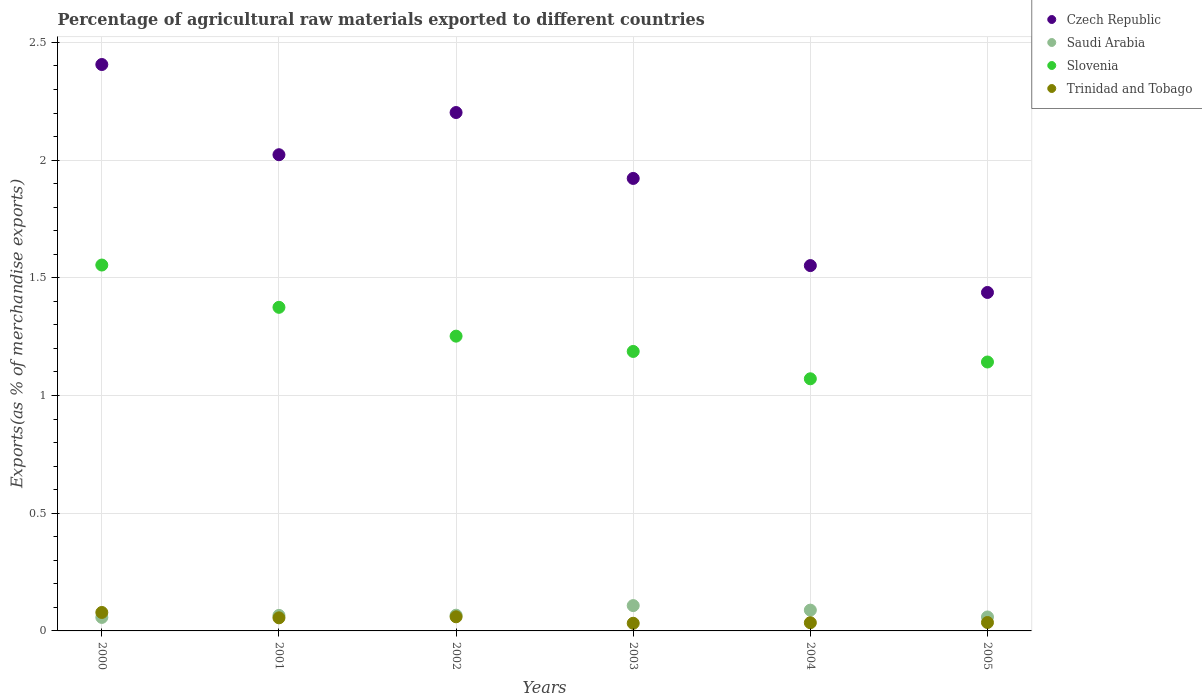How many different coloured dotlines are there?
Offer a very short reply. 4. Is the number of dotlines equal to the number of legend labels?
Keep it short and to the point. Yes. What is the percentage of exports to different countries in Saudi Arabia in 2004?
Keep it short and to the point. 0.09. Across all years, what is the maximum percentage of exports to different countries in Trinidad and Tobago?
Give a very brief answer. 0.08. Across all years, what is the minimum percentage of exports to different countries in Slovenia?
Your answer should be compact. 1.07. What is the total percentage of exports to different countries in Saudi Arabia in the graph?
Keep it short and to the point. 0.45. What is the difference between the percentage of exports to different countries in Saudi Arabia in 2002 and that in 2005?
Your answer should be compact. 0.01. What is the difference between the percentage of exports to different countries in Czech Republic in 2003 and the percentage of exports to different countries in Saudi Arabia in 2000?
Your answer should be very brief. 1.86. What is the average percentage of exports to different countries in Trinidad and Tobago per year?
Offer a terse response. 0.05. In the year 2003, what is the difference between the percentage of exports to different countries in Trinidad and Tobago and percentage of exports to different countries in Slovenia?
Offer a very short reply. -1.15. In how many years, is the percentage of exports to different countries in Trinidad and Tobago greater than 1.1 %?
Your answer should be very brief. 0. What is the ratio of the percentage of exports to different countries in Saudi Arabia in 2002 to that in 2003?
Offer a terse response. 0.62. Is the difference between the percentage of exports to different countries in Trinidad and Tobago in 2000 and 2001 greater than the difference between the percentage of exports to different countries in Slovenia in 2000 and 2001?
Your answer should be compact. No. What is the difference between the highest and the second highest percentage of exports to different countries in Slovenia?
Provide a succinct answer. 0.18. What is the difference between the highest and the lowest percentage of exports to different countries in Slovenia?
Ensure brevity in your answer.  0.48. Is the sum of the percentage of exports to different countries in Trinidad and Tobago in 2000 and 2005 greater than the maximum percentage of exports to different countries in Slovenia across all years?
Your answer should be compact. No. Is it the case that in every year, the sum of the percentage of exports to different countries in Czech Republic and percentage of exports to different countries in Slovenia  is greater than the sum of percentage of exports to different countries in Trinidad and Tobago and percentage of exports to different countries in Saudi Arabia?
Make the answer very short. No. Does the percentage of exports to different countries in Saudi Arabia monotonically increase over the years?
Make the answer very short. No. Is the percentage of exports to different countries in Trinidad and Tobago strictly greater than the percentage of exports to different countries in Czech Republic over the years?
Your response must be concise. No. Is the percentage of exports to different countries in Saudi Arabia strictly less than the percentage of exports to different countries in Czech Republic over the years?
Offer a terse response. Yes. How many dotlines are there?
Your answer should be very brief. 4. How many years are there in the graph?
Your answer should be very brief. 6. Are the values on the major ticks of Y-axis written in scientific E-notation?
Your answer should be very brief. No. Where does the legend appear in the graph?
Make the answer very short. Top right. How many legend labels are there?
Your answer should be very brief. 4. What is the title of the graph?
Keep it short and to the point. Percentage of agricultural raw materials exported to different countries. Does "Guam" appear as one of the legend labels in the graph?
Keep it short and to the point. No. What is the label or title of the X-axis?
Make the answer very short. Years. What is the label or title of the Y-axis?
Offer a terse response. Exports(as % of merchandise exports). What is the Exports(as % of merchandise exports) of Czech Republic in 2000?
Your answer should be compact. 2.41. What is the Exports(as % of merchandise exports) of Saudi Arabia in 2000?
Provide a short and direct response. 0.06. What is the Exports(as % of merchandise exports) in Slovenia in 2000?
Give a very brief answer. 1.55. What is the Exports(as % of merchandise exports) of Trinidad and Tobago in 2000?
Make the answer very short. 0.08. What is the Exports(as % of merchandise exports) of Czech Republic in 2001?
Offer a very short reply. 2.02. What is the Exports(as % of merchandise exports) in Saudi Arabia in 2001?
Make the answer very short. 0.07. What is the Exports(as % of merchandise exports) in Slovenia in 2001?
Your answer should be very brief. 1.37. What is the Exports(as % of merchandise exports) in Trinidad and Tobago in 2001?
Offer a very short reply. 0.06. What is the Exports(as % of merchandise exports) of Czech Republic in 2002?
Make the answer very short. 2.2. What is the Exports(as % of merchandise exports) of Saudi Arabia in 2002?
Keep it short and to the point. 0.07. What is the Exports(as % of merchandise exports) of Slovenia in 2002?
Keep it short and to the point. 1.25. What is the Exports(as % of merchandise exports) in Trinidad and Tobago in 2002?
Offer a terse response. 0.06. What is the Exports(as % of merchandise exports) of Czech Republic in 2003?
Give a very brief answer. 1.92. What is the Exports(as % of merchandise exports) in Saudi Arabia in 2003?
Your answer should be very brief. 0.11. What is the Exports(as % of merchandise exports) in Slovenia in 2003?
Keep it short and to the point. 1.19. What is the Exports(as % of merchandise exports) in Trinidad and Tobago in 2003?
Offer a very short reply. 0.03. What is the Exports(as % of merchandise exports) of Czech Republic in 2004?
Provide a short and direct response. 1.55. What is the Exports(as % of merchandise exports) in Saudi Arabia in 2004?
Your answer should be very brief. 0.09. What is the Exports(as % of merchandise exports) of Slovenia in 2004?
Keep it short and to the point. 1.07. What is the Exports(as % of merchandise exports) in Trinidad and Tobago in 2004?
Provide a short and direct response. 0.03. What is the Exports(as % of merchandise exports) of Czech Republic in 2005?
Make the answer very short. 1.44. What is the Exports(as % of merchandise exports) in Saudi Arabia in 2005?
Ensure brevity in your answer.  0.06. What is the Exports(as % of merchandise exports) in Slovenia in 2005?
Keep it short and to the point. 1.14. What is the Exports(as % of merchandise exports) in Trinidad and Tobago in 2005?
Make the answer very short. 0.04. Across all years, what is the maximum Exports(as % of merchandise exports) of Czech Republic?
Ensure brevity in your answer.  2.41. Across all years, what is the maximum Exports(as % of merchandise exports) of Saudi Arabia?
Your response must be concise. 0.11. Across all years, what is the maximum Exports(as % of merchandise exports) in Slovenia?
Your answer should be compact. 1.55. Across all years, what is the maximum Exports(as % of merchandise exports) in Trinidad and Tobago?
Make the answer very short. 0.08. Across all years, what is the minimum Exports(as % of merchandise exports) of Czech Republic?
Ensure brevity in your answer.  1.44. Across all years, what is the minimum Exports(as % of merchandise exports) of Saudi Arabia?
Your response must be concise. 0.06. Across all years, what is the minimum Exports(as % of merchandise exports) of Slovenia?
Offer a very short reply. 1.07. Across all years, what is the minimum Exports(as % of merchandise exports) of Trinidad and Tobago?
Keep it short and to the point. 0.03. What is the total Exports(as % of merchandise exports) in Czech Republic in the graph?
Provide a succinct answer. 11.54. What is the total Exports(as % of merchandise exports) in Saudi Arabia in the graph?
Provide a short and direct response. 0.45. What is the total Exports(as % of merchandise exports) in Slovenia in the graph?
Provide a short and direct response. 7.58. What is the total Exports(as % of merchandise exports) in Trinidad and Tobago in the graph?
Ensure brevity in your answer.  0.3. What is the difference between the Exports(as % of merchandise exports) in Czech Republic in 2000 and that in 2001?
Provide a succinct answer. 0.38. What is the difference between the Exports(as % of merchandise exports) of Saudi Arabia in 2000 and that in 2001?
Keep it short and to the point. -0.01. What is the difference between the Exports(as % of merchandise exports) in Slovenia in 2000 and that in 2001?
Your answer should be compact. 0.18. What is the difference between the Exports(as % of merchandise exports) of Trinidad and Tobago in 2000 and that in 2001?
Make the answer very short. 0.02. What is the difference between the Exports(as % of merchandise exports) of Czech Republic in 2000 and that in 2002?
Keep it short and to the point. 0.2. What is the difference between the Exports(as % of merchandise exports) in Saudi Arabia in 2000 and that in 2002?
Offer a terse response. -0.01. What is the difference between the Exports(as % of merchandise exports) in Slovenia in 2000 and that in 2002?
Make the answer very short. 0.3. What is the difference between the Exports(as % of merchandise exports) of Trinidad and Tobago in 2000 and that in 2002?
Provide a short and direct response. 0.02. What is the difference between the Exports(as % of merchandise exports) of Czech Republic in 2000 and that in 2003?
Provide a short and direct response. 0.48. What is the difference between the Exports(as % of merchandise exports) in Saudi Arabia in 2000 and that in 2003?
Your answer should be compact. -0.05. What is the difference between the Exports(as % of merchandise exports) of Slovenia in 2000 and that in 2003?
Offer a terse response. 0.37. What is the difference between the Exports(as % of merchandise exports) in Trinidad and Tobago in 2000 and that in 2003?
Offer a very short reply. 0.05. What is the difference between the Exports(as % of merchandise exports) of Czech Republic in 2000 and that in 2004?
Your response must be concise. 0.85. What is the difference between the Exports(as % of merchandise exports) of Saudi Arabia in 2000 and that in 2004?
Make the answer very short. -0.03. What is the difference between the Exports(as % of merchandise exports) in Slovenia in 2000 and that in 2004?
Offer a very short reply. 0.48. What is the difference between the Exports(as % of merchandise exports) in Trinidad and Tobago in 2000 and that in 2004?
Provide a succinct answer. 0.04. What is the difference between the Exports(as % of merchandise exports) in Czech Republic in 2000 and that in 2005?
Keep it short and to the point. 0.97. What is the difference between the Exports(as % of merchandise exports) in Saudi Arabia in 2000 and that in 2005?
Offer a terse response. -0. What is the difference between the Exports(as % of merchandise exports) in Slovenia in 2000 and that in 2005?
Your answer should be very brief. 0.41. What is the difference between the Exports(as % of merchandise exports) in Trinidad and Tobago in 2000 and that in 2005?
Offer a very short reply. 0.04. What is the difference between the Exports(as % of merchandise exports) in Czech Republic in 2001 and that in 2002?
Your answer should be very brief. -0.18. What is the difference between the Exports(as % of merchandise exports) in Saudi Arabia in 2001 and that in 2002?
Ensure brevity in your answer.  -0. What is the difference between the Exports(as % of merchandise exports) of Slovenia in 2001 and that in 2002?
Your response must be concise. 0.12. What is the difference between the Exports(as % of merchandise exports) of Trinidad and Tobago in 2001 and that in 2002?
Keep it short and to the point. -0. What is the difference between the Exports(as % of merchandise exports) of Czech Republic in 2001 and that in 2003?
Offer a very short reply. 0.1. What is the difference between the Exports(as % of merchandise exports) of Saudi Arabia in 2001 and that in 2003?
Ensure brevity in your answer.  -0.04. What is the difference between the Exports(as % of merchandise exports) of Slovenia in 2001 and that in 2003?
Offer a terse response. 0.19. What is the difference between the Exports(as % of merchandise exports) of Trinidad and Tobago in 2001 and that in 2003?
Your answer should be compact. 0.02. What is the difference between the Exports(as % of merchandise exports) in Czech Republic in 2001 and that in 2004?
Keep it short and to the point. 0.47. What is the difference between the Exports(as % of merchandise exports) of Saudi Arabia in 2001 and that in 2004?
Ensure brevity in your answer.  -0.02. What is the difference between the Exports(as % of merchandise exports) of Slovenia in 2001 and that in 2004?
Make the answer very short. 0.3. What is the difference between the Exports(as % of merchandise exports) of Trinidad and Tobago in 2001 and that in 2004?
Your answer should be very brief. 0.02. What is the difference between the Exports(as % of merchandise exports) in Czech Republic in 2001 and that in 2005?
Keep it short and to the point. 0.59. What is the difference between the Exports(as % of merchandise exports) of Saudi Arabia in 2001 and that in 2005?
Make the answer very short. 0.01. What is the difference between the Exports(as % of merchandise exports) in Slovenia in 2001 and that in 2005?
Keep it short and to the point. 0.23. What is the difference between the Exports(as % of merchandise exports) of Trinidad and Tobago in 2001 and that in 2005?
Provide a short and direct response. 0.02. What is the difference between the Exports(as % of merchandise exports) of Czech Republic in 2002 and that in 2003?
Keep it short and to the point. 0.28. What is the difference between the Exports(as % of merchandise exports) in Saudi Arabia in 2002 and that in 2003?
Give a very brief answer. -0.04. What is the difference between the Exports(as % of merchandise exports) in Slovenia in 2002 and that in 2003?
Provide a succinct answer. 0.07. What is the difference between the Exports(as % of merchandise exports) in Trinidad and Tobago in 2002 and that in 2003?
Provide a short and direct response. 0.03. What is the difference between the Exports(as % of merchandise exports) of Czech Republic in 2002 and that in 2004?
Your answer should be compact. 0.65. What is the difference between the Exports(as % of merchandise exports) of Saudi Arabia in 2002 and that in 2004?
Make the answer very short. -0.02. What is the difference between the Exports(as % of merchandise exports) of Slovenia in 2002 and that in 2004?
Offer a very short reply. 0.18. What is the difference between the Exports(as % of merchandise exports) in Trinidad and Tobago in 2002 and that in 2004?
Offer a terse response. 0.03. What is the difference between the Exports(as % of merchandise exports) of Czech Republic in 2002 and that in 2005?
Give a very brief answer. 0.76. What is the difference between the Exports(as % of merchandise exports) of Saudi Arabia in 2002 and that in 2005?
Keep it short and to the point. 0.01. What is the difference between the Exports(as % of merchandise exports) of Slovenia in 2002 and that in 2005?
Ensure brevity in your answer.  0.11. What is the difference between the Exports(as % of merchandise exports) in Trinidad and Tobago in 2002 and that in 2005?
Offer a terse response. 0.02. What is the difference between the Exports(as % of merchandise exports) of Czech Republic in 2003 and that in 2004?
Give a very brief answer. 0.37. What is the difference between the Exports(as % of merchandise exports) of Saudi Arabia in 2003 and that in 2004?
Your answer should be very brief. 0.02. What is the difference between the Exports(as % of merchandise exports) in Slovenia in 2003 and that in 2004?
Ensure brevity in your answer.  0.12. What is the difference between the Exports(as % of merchandise exports) in Trinidad and Tobago in 2003 and that in 2004?
Offer a terse response. -0. What is the difference between the Exports(as % of merchandise exports) in Czech Republic in 2003 and that in 2005?
Your response must be concise. 0.48. What is the difference between the Exports(as % of merchandise exports) of Saudi Arabia in 2003 and that in 2005?
Give a very brief answer. 0.05. What is the difference between the Exports(as % of merchandise exports) in Slovenia in 2003 and that in 2005?
Provide a succinct answer. 0.04. What is the difference between the Exports(as % of merchandise exports) in Trinidad and Tobago in 2003 and that in 2005?
Give a very brief answer. -0. What is the difference between the Exports(as % of merchandise exports) of Czech Republic in 2004 and that in 2005?
Your response must be concise. 0.11. What is the difference between the Exports(as % of merchandise exports) of Saudi Arabia in 2004 and that in 2005?
Give a very brief answer. 0.03. What is the difference between the Exports(as % of merchandise exports) of Slovenia in 2004 and that in 2005?
Offer a terse response. -0.07. What is the difference between the Exports(as % of merchandise exports) of Trinidad and Tobago in 2004 and that in 2005?
Your response must be concise. -0. What is the difference between the Exports(as % of merchandise exports) of Czech Republic in 2000 and the Exports(as % of merchandise exports) of Saudi Arabia in 2001?
Your response must be concise. 2.34. What is the difference between the Exports(as % of merchandise exports) of Czech Republic in 2000 and the Exports(as % of merchandise exports) of Slovenia in 2001?
Provide a short and direct response. 1.03. What is the difference between the Exports(as % of merchandise exports) of Czech Republic in 2000 and the Exports(as % of merchandise exports) of Trinidad and Tobago in 2001?
Offer a terse response. 2.35. What is the difference between the Exports(as % of merchandise exports) in Saudi Arabia in 2000 and the Exports(as % of merchandise exports) in Slovenia in 2001?
Your response must be concise. -1.32. What is the difference between the Exports(as % of merchandise exports) in Saudi Arabia in 2000 and the Exports(as % of merchandise exports) in Trinidad and Tobago in 2001?
Keep it short and to the point. 0. What is the difference between the Exports(as % of merchandise exports) in Slovenia in 2000 and the Exports(as % of merchandise exports) in Trinidad and Tobago in 2001?
Your response must be concise. 1.5. What is the difference between the Exports(as % of merchandise exports) of Czech Republic in 2000 and the Exports(as % of merchandise exports) of Saudi Arabia in 2002?
Keep it short and to the point. 2.34. What is the difference between the Exports(as % of merchandise exports) in Czech Republic in 2000 and the Exports(as % of merchandise exports) in Slovenia in 2002?
Provide a succinct answer. 1.15. What is the difference between the Exports(as % of merchandise exports) of Czech Republic in 2000 and the Exports(as % of merchandise exports) of Trinidad and Tobago in 2002?
Ensure brevity in your answer.  2.35. What is the difference between the Exports(as % of merchandise exports) of Saudi Arabia in 2000 and the Exports(as % of merchandise exports) of Slovenia in 2002?
Provide a short and direct response. -1.19. What is the difference between the Exports(as % of merchandise exports) of Saudi Arabia in 2000 and the Exports(as % of merchandise exports) of Trinidad and Tobago in 2002?
Keep it short and to the point. -0. What is the difference between the Exports(as % of merchandise exports) of Slovenia in 2000 and the Exports(as % of merchandise exports) of Trinidad and Tobago in 2002?
Offer a terse response. 1.49. What is the difference between the Exports(as % of merchandise exports) of Czech Republic in 2000 and the Exports(as % of merchandise exports) of Saudi Arabia in 2003?
Offer a very short reply. 2.3. What is the difference between the Exports(as % of merchandise exports) in Czech Republic in 2000 and the Exports(as % of merchandise exports) in Slovenia in 2003?
Provide a short and direct response. 1.22. What is the difference between the Exports(as % of merchandise exports) of Czech Republic in 2000 and the Exports(as % of merchandise exports) of Trinidad and Tobago in 2003?
Keep it short and to the point. 2.37. What is the difference between the Exports(as % of merchandise exports) of Saudi Arabia in 2000 and the Exports(as % of merchandise exports) of Slovenia in 2003?
Make the answer very short. -1.13. What is the difference between the Exports(as % of merchandise exports) in Saudi Arabia in 2000 and the Exports(as % of merchandise exports) in Trinidad and Tobago in 2003?
Offer a terse response. 0.02. What is the difference between the Exports(as % of merchandise exports) of Slovenia in 2000 and the Exports(as % of merchandise exports) of Trinidad and Tobago in 2003?
Offer a terse response. 1.52. What is the difference between the Exports(as % of merchandise exports) of Czech Republic in 2000 and the Exports(as % of merchandise exports) of Saudi Arabia in 2004?
Keep it short and to the point. 2.32. What is the difference between the Exports(as % of merchandise exports) in Czech Republic in 2000 and the Exports(as % of merchandise exports) in Slovenia in 2004?
Your answer should be compact. 1.33. What is the difference between the Exports(as % of merchandise exports) in Czech Republic in 2000 and the Exports(as % of merchandise exports) in Trinidad and Tobago in 2004?
Your response must be concise. 2.37. What is the difference between the Exports(as % of merchandise exports) of Saudi Arabia in 2000 and the Exports(as % of merchandise exports) of Slovenia in 2004?
Your answer should be very brief. -1.01. What is the difference between the Exports(as % of merchandise exports) of Saudi Arabia in 2000 and the Exports(as % of merchandise exports) of Trinidad and Tobago in 2004?
Your answer should be very brief. 0.02. What is the difference between the Exports(as % of merchandise exports) in Slovenia in 2000 and the Exports(as % of merchandise exports) in Trinidad and Tobago in 2004?
Keep it short and to the point. 1.52. What is the difference between the Exports(as % of merchandise exports) in Czech Republic in 2000 and the Exports(as % of merchandise exports) in Saudi Arabia in 2005?
Give a very brief answer. 2.35. What is the difference between the Exports(as % of merchandise exports) in Czech Republic in 2000 and the Exports(as % of merchandise exports) in Slovenia in 2005?
Your response must be concise. 1.26. What is the difference between the Exports(as % of merchandise exports) in Czech Republic in 2000 and the Exports(as % of merchandise exports) in Trinidad and Tobago in 2005?
Make the answer very short. 2.37. What is the difference between the Exports(as % of merchandise exports) in Saudi Arabia in 2000 and the Exports(as % of merchandise exports) in Slovenia in 2005?
Offer a terse response. -1.08. What is the difference between the Exports(as % of merchandise exports) in Saudi Arabia in 2000 and the Exports(as % of merchandise exports) in Trinidad and Tobago in 2005?
Ensure brevity in your answer.  0.02. What is the difference between the Exports(as % of merchandise exports) in Slovenia in 2000 and the Exports(as % of merchandise exports) in Trinidad and Tobago in 2005?
Your response must be concise. 1.52. What is the difference between the Exports(as % of merchandise exports) in Czech Republic in 2001 and the Exports(as % of merchandise exports) in Saudi Arabia in 2002?
Give a very brief answer. 1.96. What is the difference between the Exports(as % of merchandise exports) of Czech Republic in 2001 and the Exports(as % of merchandise exports) of Slovenia in 2002?
Your response must be concise. 0.77. What is the difference between the Exports(as % of merchandise exports) in Czech Republic in 2001 and the Exports(as % of merchandise exports) in Trinidad and Tobago in 2002?
Keep it short and to the point. 1.96. What is the difference between the Exports(as % of merchandise exports) in Saudi Arabia in 2001 and the Exports(as % of merchandise exports) in Slovenia in 2002?
Keep it short and to the point. -1.19. What is the difference between the Exports(as % of merchandise exports) in Saudi Arabia in 2001 and the Exports(as % of merchandise exports) in Trinidad and Tobago in 2002?
Offer a very short reply. 0.01. What is the difference between the Exports(as % of merchandise exports) of Slovenia in 2001 and the Exports(as % of merchandise exports) of Trinidad and Tobago in 2002?
Ensure brevity in your answer.  1.31. What is the difference between the Exports(as % of merchandise exports) of Czech Republic in 2001 and the Exports(as % of merchandise exports) of Saudi Arabia in 2003?
Offer a very short reply. 1.92. What is the difference between the Exports(as % of merchandise exports) of Czech Republic in 2001 and the Exports(as % of merchandise exports) of Slovenia in 2003?
Give a very brief answer. 0.84. What is the difference between the Exports(as % of merchandise exports) in Czech Republic in 2001 and the Exports(as % of merchandise exports) in Trinidad and Tobago in 2003?
Ensure brevity in your answer.  1.99. What is the difference between the Exports(as % of merchandise exports) in Saudi Arabia in 2001 and the Exports(as % of merchandise exports) in Slovenia in 2003?
Offer a terse response. -1.12. What is the difference between the Exports(as % of merchandise exports) in Slovenia in 2001 and the Exports(as % of merchandise exports) in Trinidad and Tobago in 2003?
Your answer should be very brief. 1.34. What is the difference between the Exports(as % of merchandise exports) of Czech Republic in 2001 and the Exports(as % of merchandise exports) of Saudi Arabia in 2004?
Your answer should be very brief. 1.93. What is the difference between the Exports(as % of merchandise exports) in Czech Republic in 2001 and the Exports(as % of merchandise exports) in Slovenia in 2004?
Provide a succinct answer. 0.95. What is the difference between the Exports(as % of merchandise exports) in Czech Republic in 2001 and the Exports(as % of merchandise exports) in Trinidad and Tobago in 2004?
Provide a succinct answer. 1.99. What is the difference between the Exports(as % of merchandise exports) in Saudi Arabia in 2001 and the Exports(as % of merchandise exports) in Slovenia in 2004?
Your answer should be very brief. -1.01. What is the difference between the Exports(as % of merchandise exports) in Saudi Arabia in 2001 and the Exports(as % of merchandise exports) in Trinidad and Tobago in 2004?
Offer a terse response. 0.03. What is the difference between the Exports(as % of merchandise exports) of Slovenia in 2001 and the Exports(as % of merchandise exports) of Trinidad and Tobago in 2004?
Offer a very short reply. 1.34. What is the difference between the Exports(as % of merchandise exports) of Czech Republic in 2001 and the Exports(as % of merchandise exports) of Saudi Arabia in 2005?
Keep it short and to the point. 1.96. What is the difference between the Exports(as % of merchandise exports) in Czech Republic in 2001 and the Exports(as % of merchandise exports) in Slovenia in 2005?
Make the answer very short. 0.88. What is the difference between the Exports(as % of merchandise exports) in Czech Republic in 2001 and the Exports(as % of merchandise exports) in Trinidad and Tobago in 2005?
Provide a succinct answer. 1.99. What is the difference between the Exports(as % of merchandise exports) of Saudi Arabia in 2001 and the Exports(as % of merchandise exports) of Slovenia in 2005?
Keep it short and to the point. -1.08. What is the difference between the Exports(as % of merchandise exports) of Saudi Arabia in 2001 and the Exports(as % of merchandise exports) of Trinidad and Tobago in 2005?
Give a very brief answer. 0.03. What is the difference between the Exports(as % of merchandise exports) of Slovenia in 2001 and the Exports(as % of merchandise exports) of Trinidad and Tobago in 2005?
Your response must be concise. 1.34. What is the difference between the Exports(as % of merchandise exports) in Czech Republic in 2002 and the Exports(as % of merchandise exports) in Saudi Arabia in 2003?
Provide a succinct answer. 2.09. What is the difference between the Exports(as % of merchandise exports) in Czech Republic in 2002 and the Exports(as % of merchandise exports) in Slovenia in 2003?
Provide a succinct answer. 1.01. What is the difference between the Exports(as % of merchandise exports) in Czech Republic in 2002 and the Exports(as % of merchandise exports) in Trinidad and Tobago in 2003?
Ensure brevity in your answer.  2.17. What is the difference between the Exports(as % of merchandise exports) of Saudi Arabia in 2002 and the Exports(as % of merchandise exports) of Slovenia in 2003?
Make the answer very short. -1.12. What is the difference between the Exports(as % of merchandise exports) in Saudi Arabia in 2002 and the Exports(as % of merchandise exports) in Trinidad and Tobago in 2003?
Offer a terse response. 0.03. What is the difference between the Exports(as % of merchandise exports) of Slovenia in 2002 and the Exports(as % of merchandise exports) of Trinidad and Tobago in 2003?
Ensure brevity in your answer.  1.22. What is the difference between the Exports(as % of merchandise exports) of Czech Republic in 2002 and the Exports(as % of merchandise exports) of Saudi Arabia in 2004?
Your answer should be very brief. 2.11. What is the difference between the Exports(as % of merchandise exports) in Czech Republic in 2002 and the Exports(as % of merchandise exports) in Slovenia in 2004?
Provide a succinct answer. 1.13. What is the difference between the Exports(as % of merchandise exports) in Czech Republic in 2002 and the Exports(as % of merchandise exports) in Trinidad and Tobago in 2004?
Offer a terse response. 2.17. What is the difference between the Exports(as % of merchandise exports) in Saudi Arabia in 2002 and the Exports(as % of merchandise exports) in Slovenia in 2004?
Offer a very short reply. -1. What is the difference between the Exports(as % of merchandise exports) in Saudi Arabia in 2002 and the Exports(as % of merchandise exports) in Trinidad and Tobago in 2004?
Provide a succinct answer. 0.03. What is the difference between the Exports(as % of merchandise exports) in Slovenia in 2002 and the Exports(as % of merchandise exports) in Trinidad and Tobago in 2004?
Offer a very short reply. 1.22. What is the difference between the Exports(as % of merchandise exports) in Czech Republic in 2002 and the Exports(as % of merchandise exports) in Saudi Arabia in 2005?
Make the answer very short. 2.14. What is the difference between the Exports(as % of merchandise exports) in Czech Republic in 2002 and the Exports(as % of merchandise exports) in Slovenia in 2005?
Give a very brief answer. 1.06. What is the difference between the Exports(as % of merchandise exports) of Czech Republic in 2002 and the Exports(as % of merchandise exports) of Trinidad and Tobago in 2005?
Your answer should be compact. 2.17. What is the difference between the Exports(as % of merchandise exports) of Saudi Arabia in 2002 and the Exports(as % of merchandise exports) of Slovenia in 2005?
Provide a succinct answer. -1.08. What is the difference between the Exports(as % of merchandise exports) in Saudi Arabia in 2002 and the Exports(as % of merchandise exports) in Trinidad and Tobago in 2005?
Make the answer very short. 0.03. What is the difference between the Exports(as % of merchandise exports) in Slovenia in 2002 and the Exports(as % of merchandise exports) in Trinidad and Tobago in 2005?
Keep it short and to the point. 1.22. What is the difference between the Exports(as % of merchandise exports) of Czech Republic in 2003 and the Exports(as % of merchandise exports) of Saudi Arabia in 2004?
Your answer should be very brief. 1.83. What is the difference between the Exports(as % of merchandise exports) of Czech Republic in 2003 and the Exports(as % of merchandise exports) of Slovenia in 2004?
Offer a terse response. 0.85. What is the difference between the Exports(as % of merchandise exports) in Czech Republic in 2003 and the Exports(as % of merchandise exports) in Trinidad and Tobago in 2004?
Provide a succinct answer. 1.89. What is the difference between the Exports(as % of merchandise exports) of Saudi Arabia in 2003 and the Exports(as % of merchandise exports) of Slovenia in 2004?
Ensure brevity in your answer.  -0.96. What is the difference between the Exports(as % of merchandise exports) in Saudi Arabia in 2003 and the Exports(as % of merchandise exports) in Trinidad and Tobago in 2004?
Offer a terse response. 0.07. What is the difference between the Exports(as % of merchandise exports) of Slovenia in 2003 and the Exports(as % of merchandise exports) of Trinidad and Tobago in 2004?
Your answer should be very brief. 1.15. What is the difference between the Exports(as % of merchandise exports) in Czech Republic in 2003 and the Exports(as % of merchandise exports) in Saudi Arabia in 2005?
Keep it short and to the point. 1.86. What is the difference between the Exports(as % of merchandise exports) of Czech Republic in 2003 and the Exports(as % of merchandise exports) of Slovenia in 2005?
Your response must be concise. 0.78. What is the difference between the Exports(as % of merchandise exports) of Czech Republic in 2003 and the Exports(as % of merchandise exports) of Trinidad and Tobago in 2005?
Make the answer very short. 1.89. What is the difference between the Exports(as % of merchandise exports) of Saudi Arabia in 2003 and the Exports(as % of merchandise exports) of Slovenia in 2005?
Ensure brevity in your answer.  -1.03. What is the difference between the Exports(as % of merchandise exports) of Saudi Arabia in 2003 and the Exports(as % of merchandise exports) of Trinidad and Tobago in 2005?
Give a very brief answer. 0.07. What is the difference between the Exports(as % of merchandise exports) in Slovenia in 2003 and the Exports(as % of merchandise exports) in Trinidad and Tobago in 2005?
Ensure brevity in your answer.  1.15. What is the difference between the Exports(as % of merchandise exports) in Czech Republic in 2004 and the Exports(as % of merchandise exports) in Saudi Arabia in 2005?
Ensure brevity in your answer.  1.49. What is the difference between the Exports(as % of merchandise exports) of Czech Republic in 2004 and the Exports(as % of merchandise exports) of Slovenia in 2005?
Your response must be concise. 0.41. What is the difference between the Exports(as % of merchandise exports) in Czech Republic in 2004 and the Exports(as % of merchandise exports) in Trinidad and Tobago in 2005?
Your answer should be very brief. 1.52. What is the difference between the Exports(as % of merchandise exports) of Saudi Arabia in 2004 and the Exports(as % of merchandise exports) of Slovenia in 2005?
Offer a terse response. -1.05. What is the difference between the Exports(as % of merchandise exports) of Saudi Arabia in 2004 and the Exports(as % of merchandise exports) of Trinidad and Tobago in 2005?
Ensure brevity in your answer.  0.05. What is the difference between the Exports(as % of merchandise exports) of Slovenia in 2004 and the Exports(as % of merchandise exports) of Trinidad and Tobago in 2005?
Offer a terse response. 1.04. What is the average Exports(as % of merchandise exports) in Czech Republic per year?
Keep it short and to the point. 1.92. What is the average Exports(as % of merchandise exports) in Saudi Arabia per year?
Your response must be concise. 0.07. What is the average Exports(as % of merchandise exports) of Slovenia per year?
Ensure brevity in your answer.  1.26. What is the average Exports(as % of merchandise exports) of Trinidad and Tobago per year?
Your answer should be very brief. 0.05. In the year 2000, what is the difference between the Exports(as % of merchandise exports) in Czech Republic and Exports(as % of merchandise exports) in Saudi Arabia?
Offer a terse response. 2.35. In the year 2000, what is the difference between the Exports(as % of merchandise exports) in Czech Republic and Exports(as % of merchandise exports) in Slovenia?
Ensure brevity in your answer.  0.85. In the year 2000, what is the difference between the Exports(as % of merchandise exports) in Czech Republic and Exports(as % of merchandise exports) in Trinidad and Tobago?
Give a very brief answer. 2.33. In the year 2000, what is the difference between the Exports(as % of merchandise exports) of Saudi Arabia and Exports(as % of merchandise exports) of Slovenia?
Your answer should be very brief. -1.5. In the year 2000, what is the difference between the Exports(as % of merchandise exports) in Saudi Arabia and Exports(as % of merchandise exports) in Trinidad and Tobago?
Offer a terse response. -0.02. In the year 2000, what is the difference between the Exports(as % of merchandise exports) in Slovenia and Exports(as % of merchandise exports) in Trinidad and Tobago?
Keep it short and to the point. 1.48. In the year 2001, what is the difference between the Exports(as % of merchandise exports) in Czech Republic and Exports(as % of merchandise exports) in Saudi Arabia?
Your answer should be compact. 1.96. In the year 2001, what is the difference between the Exports(as % of merchandise exports) in Czech Republic and Exports(as % of merchandise exports) in Slovenia?
Provide a short and direct response. 0.65. In the year 2001, what is the difference between the Exports(as % of merchandise exports) of Czech Republic and Exports(as % of merchandise exports) of Trinidad and Tobago?
Offer a terse response. 1.97. In the year 2001, what is the difference between the Exports(as % of merchandise exports) in Saudi Arabia and Exports(as % of merchandise exports) in Slovenia?
Your answer should be compact. -1.31. In the year 2001, what is the difference between the Exports(as % of merchandise exports) of Saudi Arabia and Exports(as % of merchandise exports) of Trinidad and Tobago?
Offer a very short reply. 0.01. In the year 2001, what is the difference between the Exports(as % of merchandise exports) in Slovenia and Exports(as % of merchandise exports) in Trinidad and Tobago?
Make the answer very short. 1.32. In the year 2002, what is the difference between the Exports(as % of merchandise exports) in Czech Republic and Exports(as % of merchandise exports) in Saudi Arabia?
Offer a very short reply. 2.14. In the year 2002, what is the difference between the Exports(as % of merchandise exports) in Czech Republic and Exports(as % of merchandise exports) in Slovenia?
Give a very brief answer. 0.95. In the year 2002, what is the difference between the Exports(as % of merchandise exports) in Czech Republic and Exports(as % of merchandise exports) in Trinidad and Tobago?
Your response must be concise. 2.14. In the year 2002, what is the difference between the Exports(as % of merchandise exports) of Saudi Arabia and Exports(as % of merchandise exports) of Slovenia?
Ensure brevity in your answer.  -1.19. In the year 2002, what is the difference between the Exports(as % of merchandise exports) in Saudi Arabia and Exports(as % of merchandise exports) in Trinidad and Tobago?
Ensure brevity in your answer.  0.01. In the year 2002, what is the difference between the Exports(as % of merchandise exports) of Slovenia and Exports(as % of merchandise exports) of Trinidad and Tobago?
Keep it short and to the point. 1.19. In the year 2003, what is the difference between the Exports(as % of merchandise exports) in Czech Republic and Exports(as % of merchandise exports) in Saudi Arabia?
Provide a succinct answer. 1.81. In the year 2003, what is the difference between the Exports(as % of merchandise exports) in Czech Republic and Exports(as % of merchandise exports) in Slovenia?
Keep it short and to the point. 0.73. In the year 2003, what is the difference between the Exports(as % of merchandise exports) in Czech Republic and Exports(as % of merchandise exports) in Trinidad and Tobago?
Offer a very short reply. 1.89. In the year 2003, what is the difference between the Exports(as % of merchandise exports) of Saudi Arabia and Exports(as % of merchandise exports) of Slovenia?
Offer a terse response. -1.08. In the year 2003, what is the difference between the Exports(as % of merchandise exports) in Saudi Arabia and Exports(as % of merchandise exports) in Trinidad and Tobago?
Make the answer very short. 0.08. In the year 2003, what is the difference between the Exports(as % of merchandise exports) of Slovenia and Exports(as % of merchandise exports) of Trinidad and Tobago?
Keep it short and to the point. 1.15. In the year 2004, what is the difference between the Exports(as % of merchandise exports) of Czech Republic and Exports(as % of merchandise exports) of Saudi Arabia?
Keep it short and to the point. 1.46. In the year 2004, what is the difference between the Exports(as % of merchandise exports) in Czech Republic and Exports(as % of merchandise exports) in Slovenia?
Make the answer very short. 0.48. In the year 2004, what is the difference between the Exports(as % of merchandise exports) of Czech Republic and Exports(as % of merchandise exports) of Trinidad and Tobago?
Your answer should be compact. 1.52. In the year 2004, what is the difference between the Exports(as % of merchandise exports) in Saudi Arabia and Exports(as % of merchandise exports) in Slovenia?
Provide a succinct answer. -0.98. In the year 2004, what is the difference between the Exports(as % of merchandise exports) of Saudi Arabia and Exports(as % of merchandise exports) of Trinidad and Tobago?
Make the answer very short. 0.05. In the year 2004, what is the difference between the Exports(as % of merchandise exports) in Slovenia and Exports(as % of merchandise exports) in Trinidad and Tobago?
Your response must be concise. 1.04. In the year 2005, what is the difference between the Exports(as % of merchandise exports) in Czech Republic and Exports(as % of merchandise exports) in Saudi Arabia?
Your response must be concise. 1.38. In the year 2005, what is the difference between the Exports(as % of merchandise exports) in Czech Republic and Exports(as % of merchandise exports) in Slovenia?
Offer a very short reply. 0.3. In the year 2005, what is the difference between the Exports(as % of merchandise exports) in Czech Republic and Exports(as % of merchandise exports) in Trinidad and Tobago?
Offer a very short reply. 1.4. In the year 2005, what is the difference between the Exports(as % of merchandise exports) in Saudi Arabia and Exports(as % of merchandise exports) in Slovenia?
Your answer should be very brief. -1.08. In the year 2005, what is the difference between the Exports(as % of merchandise exports) in Saudi Arabia and Exports(as % of merchandise exports) in Trinidad and Tobago?
Your response must be concise. 0.02. In the year 2005, what is the difference between the Exports(as % of merchandise exports) in Slovenia and Exports(as % of merchandise exports) in Trinidad and Tobago?
Offer a very short reply. 1.11. What is the ratio of the Exports(as % of merchandise exports) in Czech Republic in 2000 to that in 2001?
Keep it short and to the point. 1.19. What is the ratio of the Exports(as % of merchandise exports) in Saudi Arabia in 2000 to that in 2001?
Offer a terse response. 0.87. What is the ratio of the Exports(as % of merchandise exports) of Slovenia in 2000 to that in 2001?
Make the answer very short. 1.13. What is the ratio of the Exports(as % of merchandise exports) in Trinidad and Tobago in 2000 to that in 2001?
Keep it short and to the point. 1.41. What is the ratio of the Exports(as % of merchandise exports) in Czech Republic in 2000 to that in 2002?
Offer a terse response. 1.09. What is the ratio of the Exports(as % of merchandise exports) in Saudi Arabia in 2000 to that in 2002?
Your response must be concise. 0.86. What is the ratio of the Exports(as % of merchandise exports) of Slovenia in 2000 to that in 2002?
Give a very brief answer. 1.24. What is the ratio of the Exports(as % of merchandise exports) of Trinidad and Tobago in 2000 to that in 2002?
Offer a very short reply. 1.31. What is the ratio of the Exports(as % of merchandise exports) of Czech Republic in 2000 to that in 2003?
Your response must be concise. 1.25. What is the ratio of the Exports(as % of merchandise exports) in Saudi Arabia in 2000 to that in 2003?
Your answer should be very brief. 0.53. What is the ratio of the Exports(as % of merchandise exports) of Slovenia in 2000 to that in 2003?
Provide a short and direct response. 1.31. What is the ratio of the Exports(as % of merchandise exports) in Trinidad and Tobago in 2000 to that in 2003?
Make the answer very short. 2.41. What is the ratio of the Exports(as % of merchandise exports) of Czech Republic in 2000 to that in 2004?
Keep it short and to the point. 1.55. What is the ratio of the Exports(as % of merchandise exports) in Saudi Arabia in 2000 to that in 2004?
Your response must be concise. 0.65. What is the ratio of the Exports(as % of merchandise exports) in Slovenia in 2000 to that in 2004?
Your answer should be very brief. 1.45. What is the ratio of the Exports(as % of merchandise exports) in Trinidad and Tobago in 2000 to that in 2004?
Make the answer very short. 2.25. What is the ratio of the Exports(as % of merchandise exports) in Czech Republic in 2000 to that in 2005?
Your answer should be compact. 1.67. What is the ratio of the Exports(as % of merchandise exports) of Saudi Arabia in 2000 to that in 2005?
Give a very brief answer. 0.97. What is the ratio of the Exports(as % of merchandise exports) in Slovenia in 2000 to that in 2005?
Offer a very short reply. 1.36. What is the ratio of the Exports(as % of merchandise exports) of Trinidad and Tobago in 2000 to that in 2005?
Give a very brief answer. 2.2. What is the ratio of the Exports(as % of merchandise exports) of Czech Republic in 2001 to that in 2002?
Your answer should be very brief. 0.92. What is the ratio of the Exports(as % of merchandise exports) of Saudi Arabia in 2001 to that in 2002?
Your response must be concise. 0.98. What is the ratio of the Exports(as % of merchandise exports) in Slovenia in 2001 to that in 2002?
Make the answer very short. 1.1. What is the ratio of the Exports(as % of merchandise exports) in Trinidad and Tobago in 2001 to that in 2002?
Provide a succinct answer. 0.93. What is the ratio of the Exports(as % of merchandise exports) in Czech Republic in 2001 to that in 2003?
Give a very brief answer. 1.05. What is the ratio of the Exports(as % of merchandise exports) of Saudi Arabia in 2001 to that in 2003?
Offer a terse response. 0.61. What is the ratio of the Exports(as % of merchandise exports) in Slovenia in 2001 to that in 2003?
Your response must be concise. 1.16. What is the ratio of the Exports(as % of merchandise exports) in Trinidad and Tobago in 2001 to that in 2003?
Offer a terse response. 1.71. What is the ratio of the Exports(as % of merchandise exports) in Czech Republic in 2001 to that in 2004?
Offer a terse response. 1.3. What is the ratio of the Exports(as % of merchandise exports) in Saudi Arabia in 2001 to that in 2004?
Give a very brief answer. 0.75. What is the ratio of the Exports(as % of merchandise exports) of Slovenia in 2001 to that in 2004?
Your answer should be compact. 1.28. What is the ratio of the Exports(as % of merchandise exports) of Trinidad and Tobago in 2001 to that in 2004?
Provide a succinct answer. 1.6. What is the ratio of the Exports(as % of merchandise exports) in Czech Republic in 2001 to that in 2005?
Your response must be concise. 1.41. What is the ratio of the Exports(as % of merchandise exports) in Saudi Arabia in 2001 to that in 2005?
Give a very brief answer. 1.11. What is the ratio of the Exports(as % of merchandise exports) in Slovenia in 2001 to that in 2005?
Ensure brevity in your answer.  1.2. What is the ratio of the Exports(as % of merchandise exports) in Trinidad and Tobago in 2001 to that in 2005?
Keep it short and to the point. 1.56. What is the ratio of the Exports(as % of merchandise exports) in Czech Republic in 2002 to that in 2003?
Provide a short and direct response. 1.15. What is the ratio of the Exports(as % of merchandise exports) of Saudi Arabia in 2002 to that in 2003?
Your response must be concise. 0.62. What is the ratio of the Exports(as % of merchandise exports) in Slovenia in 2002 to that in 2003?
Ensure brevity in your answer.  1.05. What is the ratio of the Exports(as % of merchandise exports) of Trinidad and Tobago in 2002 to that in 2003?
Your answer should be compact. 1.84. What is the ratio of the Exports(as % of merchandise exports) in Czech Republic in 2002 to that in 2004?
Provide a succinct answer. 1.42. What is the ratio of the Exports(as % of merchandise exports) of Saudi Arabia in 2002 to that in 2004?
Give a very brief answer. 0.76. What is the ratio of the Exports(as % of merchandise exports) in Slovenia in 2002 to that in 2004?
Your answer should be very brief. 1.17. What is the ratio of the Exports(as % of merchandise exports) of Trinidad and Tobago in 2002 to that in 2004?
Your answer should be compact. 1.72. What is the ratio of the Exports(as % of merchandise exports) of Czech Republic in 2002 to that in 2005?
Keep it short and to the point. 1.53. What is the ratio of the Exports(as % of merchandise exports) of Saudi Arabia in 2002 to that in 2005?
Ensure brevity in your answer.  1.13. What is the ratio of the Exports(as % of merchandise exports) of Slovenia in 2002 to that in 2005?
Make the answer very short. 1.1. What is the ratio of the Exports(as % of merchandise exports) of Trinidad and Tobago in 2002 to that in 2005?
Keep it short and to the point. 1.68. What is the ratio of the Exports(as % of merchandise exports) in Czech Republic in 2003 to that in 2004?
Provide a short and direct response. 1.24. What is the ratio of the Exports(as % of merchandise exports) of Saudi Arabia in 2003 to that in 2004?
Give a very brief answer. 1.22. What is the ratio of the Exports(as % of merchandise exports) in Slovenia in 2003 to that in 2004?
Keep it short and to the point. 1.11. What is the ratio of the Exports(as % of merchandise exports) in Trinidad and Tobago in 2003 to that in 2004?
Your answer should be very brief. 0.93. What is the ratio of the Exports(as % of merchandise exports) in Czech Republic in 2003 to that in 2005?
Provide a succinct answer. 1.34. What is the ratio of the Exports(as % of merchandise exports) of Saudi Arabia in 2003 to that in 2005?
Your response must be concise. 1.82. What is the ratio of the Exports(as % of merchandise exports) of Slovenia in 2003 to that in 2005?
Give a very brief answer. 1.04. What is the ratio of the Exports(as % of merchandise exports) in Trinidad and Tobago in 2003 to that in 2005?
Make the answer very short. 0.91. What is the ratio of the Exports(as % of merchandise exports) in Czech Republic in 2004 to that in 2005?
Your answer should be very brief. 1.08. What is the ratio of the Exports(as % of merchandise exports) of Saudi Arabia in 2004 to that in 2005?
Your response must be concise. 1.49. What is the ratio of the Exports(as % of merchandise exports) of Slovenia in 2004 to that in 2005?
Give a very brief answer. 0.94. What is the ratio of the Exports(as % of merchandise exports) of Trinidad and Tobago in 2004 to that in 2005?
Make the answer very short. 0.98. What is the difference between the highest and the second highest Exports(as % of merchandise exports) of Czech Republic?
Keep it short and to the point. 0.2. What is the difference between the highest and the second highest Exports(as % of merchandise exports) of Saudi Arabia?
Offer a terse response. 0.02. What is the difference between the highest and the second highest Exports(as % of merchandise exports) in Slovenia?
Your response must be concise. 0.18. What is the difference between the highest and the second highest Exports(as % of merchandise exports) in Trinidad and Tobago?
Your answer should be very brief. 0.02. What is the difference between the highest and the lowest Exports(as % of merchandise exports) of Czech Republic?
Give a very brief answer. 0.97. What is the difference between the highest and the lowest Exports(as % of merchandise exports) in Saudi Arabia?
Keep it short and to the point. 0.05. What is the difference between the highest and the lowest Exports(as % of merchandise exports) of Slovenia?
Offer a very short reply. 0.48. What is the difference between the highest and the lowest Exports(as % of merchandise exports) in Trinidad and Tobago?
Your response must be concise. 0.05. 